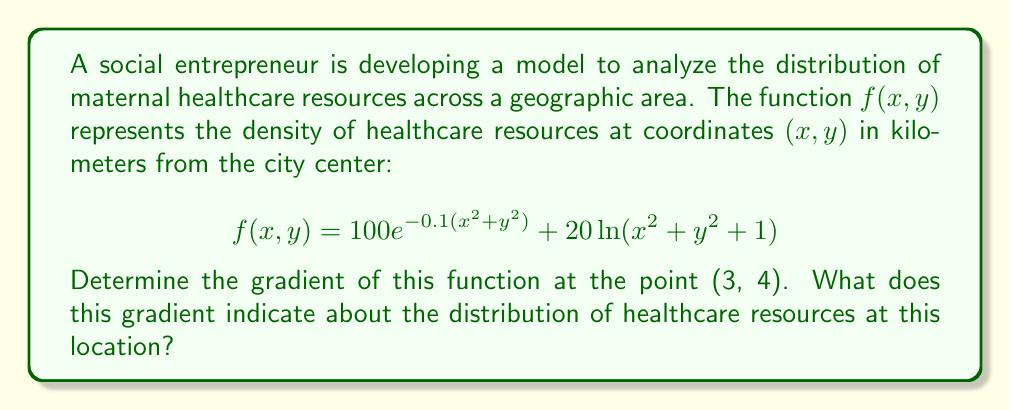Solve this math problem. To solve this problem, we need to follow these steps:

1) The gradient of a function $f(x, y)$ is defined as:

   $$\nabla f = \left(\frac{\partial f}{\partial x}, \frac{\partial f}{\partial y}\right)$$

2) Let's calculate $\frac{\partial f}{\partial x}$:
   
   $$\begin{align}
   \frac{\partial f}{\partial x} &= \frac{\partial}{\partial x}[100e^{-0.1(x^2 + y^2)}] + \frac{\partial}{\partial x}[20\ln(x^2 + y^2 + 1)] \\
   &= 100e^{-0.1(x^2 + y^2)}(-0.2x) + 20\frac{2x}{x^2 + y^2 + 1}
   \end{align}$$

3) Similarly, for $\frac{\partial f}{\partial y}$:

   $$\begin{align}
   \frac{\partial f}{\partial y} &= \frac{\partial}{\partial y}[100e^{-0.1(x^2 + y^2)}] + \frac{\partial}{\partial y}[20\ln(x^2 + y^2 + 1)] \\
   &= 100e^{-0.1(x^2 + y^2)}(-0.2y) + 20\frac{2y}{x^2 + y^2 + 1}
   \end{align}$$

4) Now, we need to evaluate these partial derivatives at the point (3, 4):

   At (3, 4): $x^2 + y^2 = 3^2 + 4^2 = 25$

   $$\begin{align}
   \frac{\partial f}{\partial x}(3,4) &= 100e^{-0.1(25)}(-0.2 \cdot 3) + 20\frac{2 \cdot 3}{25 + 1} \\
   &\approx -28.0699 + 4.6154 \approx -23.4545
   \end{align}$$

   $$\begin{align}
   \frac{\partial f}{\partial y}(3,4) &= 100e^{-0.1(25)}(-0.2 \cdot 4) + 20\frac{2 \cdot 4}{25 + 1} \\
   &\approx -37.4266 + 6.1538 \approx -31.2728
   \end{align}$$

5) Therefore, the gradient at (3, 4) is:

   $$\nabla f(3,4) \approx (-23.4545, -31.2728)$$

The gradient indicates the direction of steepest increase in the function. In this case, the negative values suggest that the density of healthcare resources is decreasing as we move away from the origin in both x and y directions. The larger magnitude in the y-component indicates a steeper decrease in that direction.
Answer: The gradient of the function at the point (3, 4) is approximately $(-23.4545, -31.2728)$. This indicates that at 3 km east and 4 km north of the city center, the density of maternal healthcare resources is decreasing most rapidly in the northward direction, and slightly less rapidly in the eastward direction. 